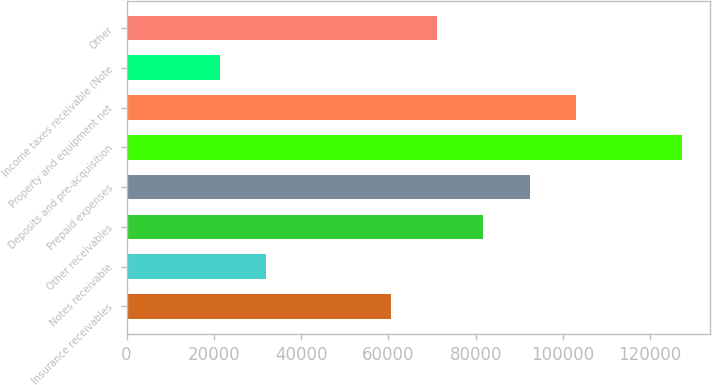Convert chart to OTSL. <chart><loc_0><loc_0><loc_500><loc_500><bar_chart><fcel>Insurance receivables<fcel>Notes receivable<fcel>Other receivables<fcel>Prepaid expenses<fcel>Deposits and pre-acquisition<fcel>Property and equipment net<fcel>Income taxes receivable (Note<fcel>Other<nl><fcel>60598<fcel>31925<fcel>81788<fcel>92383<fcel>127280<fcel>102978<fcel>21330<fcel>71193<nl></chart> 